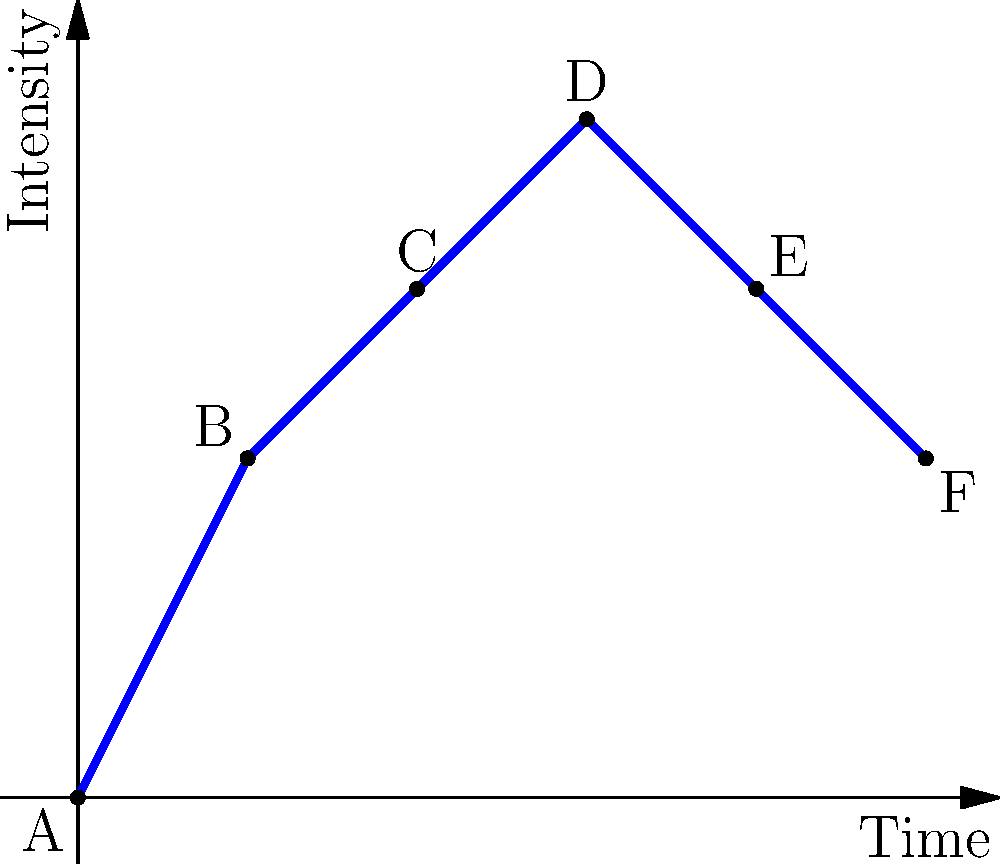As a music producer collaborating on a podcast project, you're analyzing the narrative flow and musical intensity of an episode. The graph represents the intensity of music and storytelling over time. Which point on the graph represents the climax of the episode, and how would you structure the music production around this point to enhance the storytelling? To answer this question, let's analyze the graph step-by-step:

1. The x-axis represents time, and the y-axis represents intensity (which could be a combination of narrative tension and musical intensity).

2. There are six points labeled A through F, each representing a different moment in the episode.

3. The intensity starts at zero (point A) and increases over time.

4. The highest point on the graph is point D, which occurs at time 3 and has the highest intensity value.

5. Point D represents the climax of the episode, as it's the moment of peak intensity in both storytelling and music.

6. To structure the music production around this climax:
   a) Build up: Gradually increase the musical complexity and intensity from points A to C.
   b) Climax: At point D, use the fullest arrangement and highest energy in the music.
   c) Resolution: From points E to F, gradually reduce the musical intensity and complexity.

7. This structure mirrors the storytelling arc, with the music enhancing the narrative:
   - Introduction (A to B)
   - Rising action (B to C)
   - Climax (D)
   - Falling action (E)
   - Resolution (F)

8. The music should support but not overpower the storytelling, especially at the climax (D), where the narrative should be clear and impactful.
Answer: Point D; build up to D, peak at D, then gradually decrease intensity. 